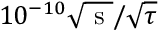Convert formula to latex. <formula><loc_0><loc_0><loc_500><loc_500>1 0 ^ { - 1 0 } \sqrt { s } / \sqrt { \tau }</formula> 